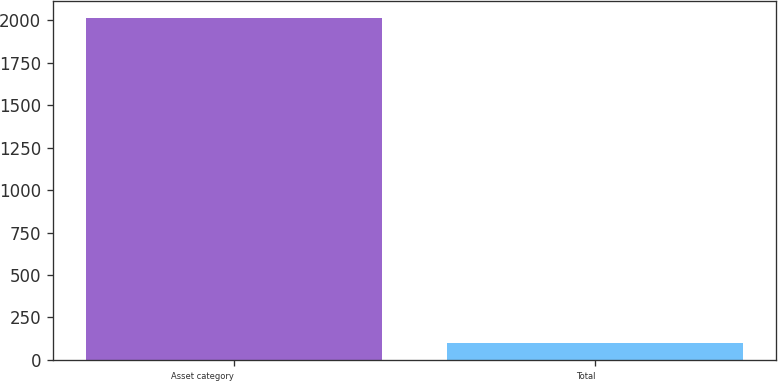Convert chart to OTSL. <chart><loc_0><loc_0><loc_500><loc_500><bar_chart><fcel>Asset category<fcel>Total<nl><fcel>2012<fcel>100<nl></chart> 